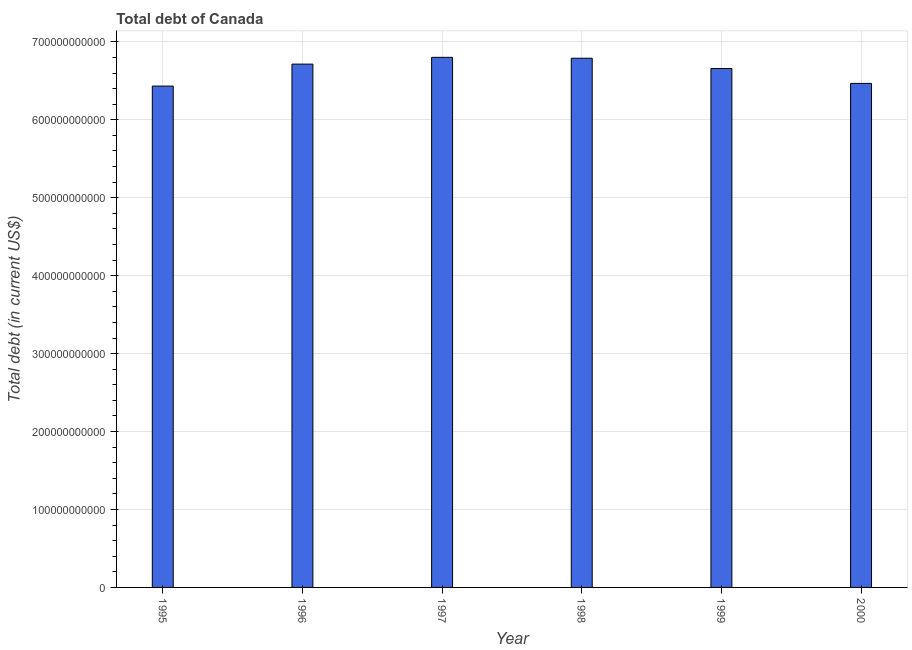Does the graph contain grids?
Provide a succinct answer. Yes. What is the title of the graph?
Offer a terse response. Total debt of Canada. What is the label or title of the Y-axis?
Give a very brief answer. Total debt (in current US$). What is the total debt in 1995?
Offer a very short reply. 6.43e+11. Across all years, what is the maximum total debt?
Your answer should be compact. 6.80e+11. Across all years, what is the minimum total debt?
Offer a very short reply. 6.43e+11. In which year was the total debt maximum?
Give a very brief answer. 1997. What is the sum of the total debt?
Make the answer very short. 3.99e+12. What is the difference between the total debt in 1995 and 1997?
Provide a short and direct response. -3.69e+1. What is the average total debt per year?
Provide a short and direct response. 6.64e+11. What is the median total debt?
Your answer should be very brief. 6.69e+11. What is the ratio of the total debt in 1997 to that in 1998?
Your answer should be compact. 1. What is the difference between the highest and the second highest total debt?
Keep it short and to the point. 1.16e+09. What is the difference between the highest and the lowest total debt?
Give a very brief answer. 3.69e+1. In how many years, is the total debt greater than the average total debt taken over all years?
Ensure brevity in your answer.  4. How many years are there in the graph?
Make the answer very short. 6. What is the difference between two consecutive major ticks on the Y-axis?
Your answer should be compact. 1.00e+11. Are the values on the major ticks of Y-axis written in scientific E-notation?
Give a very brief answer. No. What is the Total debt (in current US$) of 1995?
Offer a very short reply. 6.43e+11. What is the Total debt (in current US$) of 1996?
Make the answer very short. 6.71e+11. What is the Total debt (in current US$) of 1997?
Make the answer very short. 6.80e+11. What is the Total debt (in current US$) of 1998?
Your response must be concise. 6.79e+11. What is the Total debt (in current US$) of 1999?
Your answer should be very brief. 6.66e+11. What is the Total debt (in current US$) in 2000?
Provide a succinct answer. 6.47e+11. What is the difference between the Total debt (in current US$) in 1995 and 1996?
Your answer should be compact. -2.82e+1. What is the difference between the Total debt (in current US$) in 1995 and 1997?
Give a very brief answer. -3.69e+1. What is the difference between the Total debt (in current US$) in 1995 and 1998?
Keep it short and to the point. -3.57e+1. What is the difference between the Total debt (in current US$) in 1995 and 1999?
Make the answer very short. -2.25e+1. What is the difference between the Total debt (in current US$) in 1995 and 2000?
Offer a terse response. -3.43e+09. What is the difference between the Total debt (in current US$) in 1996 and 1997?
Ensure brevity in your answer.  -8.71e+09. What is the difference between the Total debt (in current US$) in 1996 and 1998?
Ensure brevity in your answer.  -7.54e+09. What is the difference between the Total debt (in current US$) in 1996 and 1999?
Offer a terse response. 5.66e+09. What is the difference between the Total debt (in current US$) in 1996 and 2000?
Provide a short and direct response. 2.47e+1. What is the difference between the Total debt (in current US$) in 1997 and 1998?
Give a very brief answer. 1.16e+09. What is the difference between the Total debt (in current US$) in 1997 and 1999?
Your answer should be very brief. 1.44e+1. What is the difference between the Total debt (in current US$) in 1997 and 2000?
Offer a very short reply. 3.34e+1. What is the difference between the Total debt (in current US$) in 1998 and 1999?
Your answer should be compact. 1.32e+1. What is the difference between the Total debt (in current US$) in 1998 and 2000?
Give a very brief answer. 3.23e+1. What is the difference between the Total debt (in current US$) in 1999 and 2000?
Give a very brief answer. 1.91e+1. What is the ratio of the Total debt (in current US$) in 1995 to that in 1996?
Offer a terse response. 0.96. What is the ratio of the Total debt (in current US$) in 1995 to that in 1997?
Give a very brief answer. 0.95. What is the ratio of the Total debt (in current US$) in 1995 to that in 1998?
Give a very brief answer. 0.95. What is the ratio of the Total debt (in current US$) in 1996 to that in 1999?
Your response must be concise. 1.01. What is the ratio of the Total debt (in current US$) in 1996 to that in 2000?
Ensure brevity in your answer.  1.04. What is the ratio of the Total debt (in current US$) in 1997 to that in 1999?
Provide a short and direct response. 1.02. What is the ratio of the Total debt (in current US$) in 1997 to that in 2000?
Offer a terse response. 1.05. What is the ratio of the Total debt (in current US$) in 1998 to that in 2000?
Offer a terse response. 1.05. 